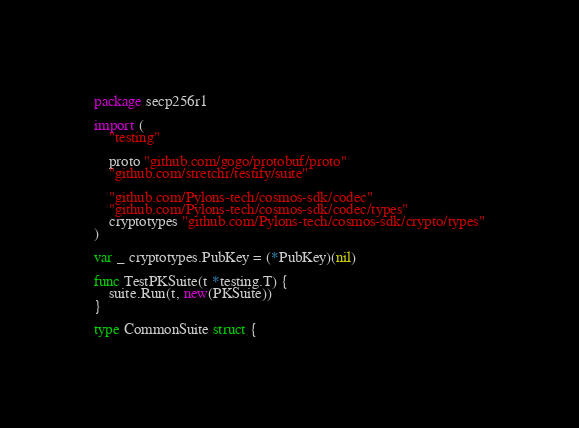<code> <loc_0><loc_0><loc_500><loc_500><_Go_>package secp256r1

import (
	"testing"

	proto "github.com/gogo/protobuf/proto"
	"github.com/stretchr/testify/suite"

	"github.com/Pylons-tech/cosmos-sdk/codec"
	"github.com/Pylons-tech/cosmos-sdk/codec/types"
	cryptotypes "github.com/Pylons-tech/cosmos-sdk/crypto/types"
)

var _ cryptotypes.PubKey = (*PubKey)(nil)

func TestPKSuite(t *testing.T) {
	suite.Run(t, new(PKSuite))
}

type CommonSuite struct {</code> 